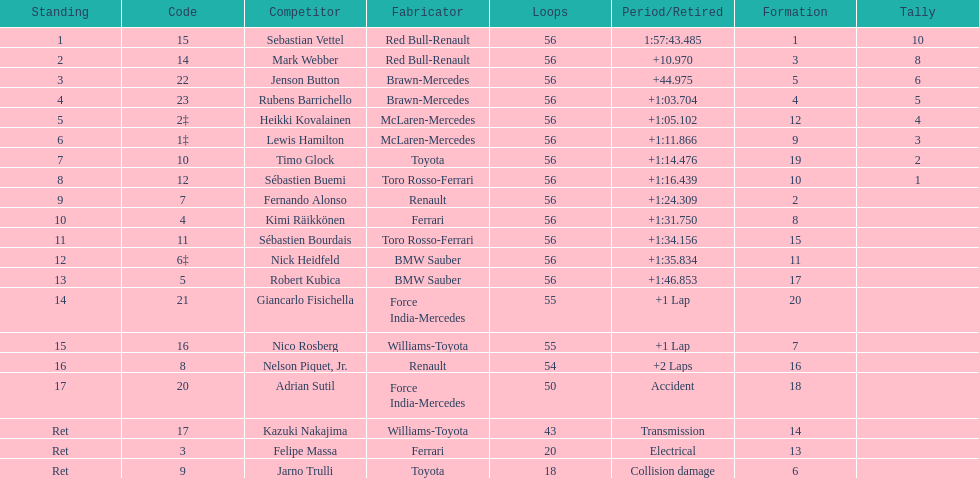What name is just previous to kazuki nakjima on the list? Adrian Sutil. 